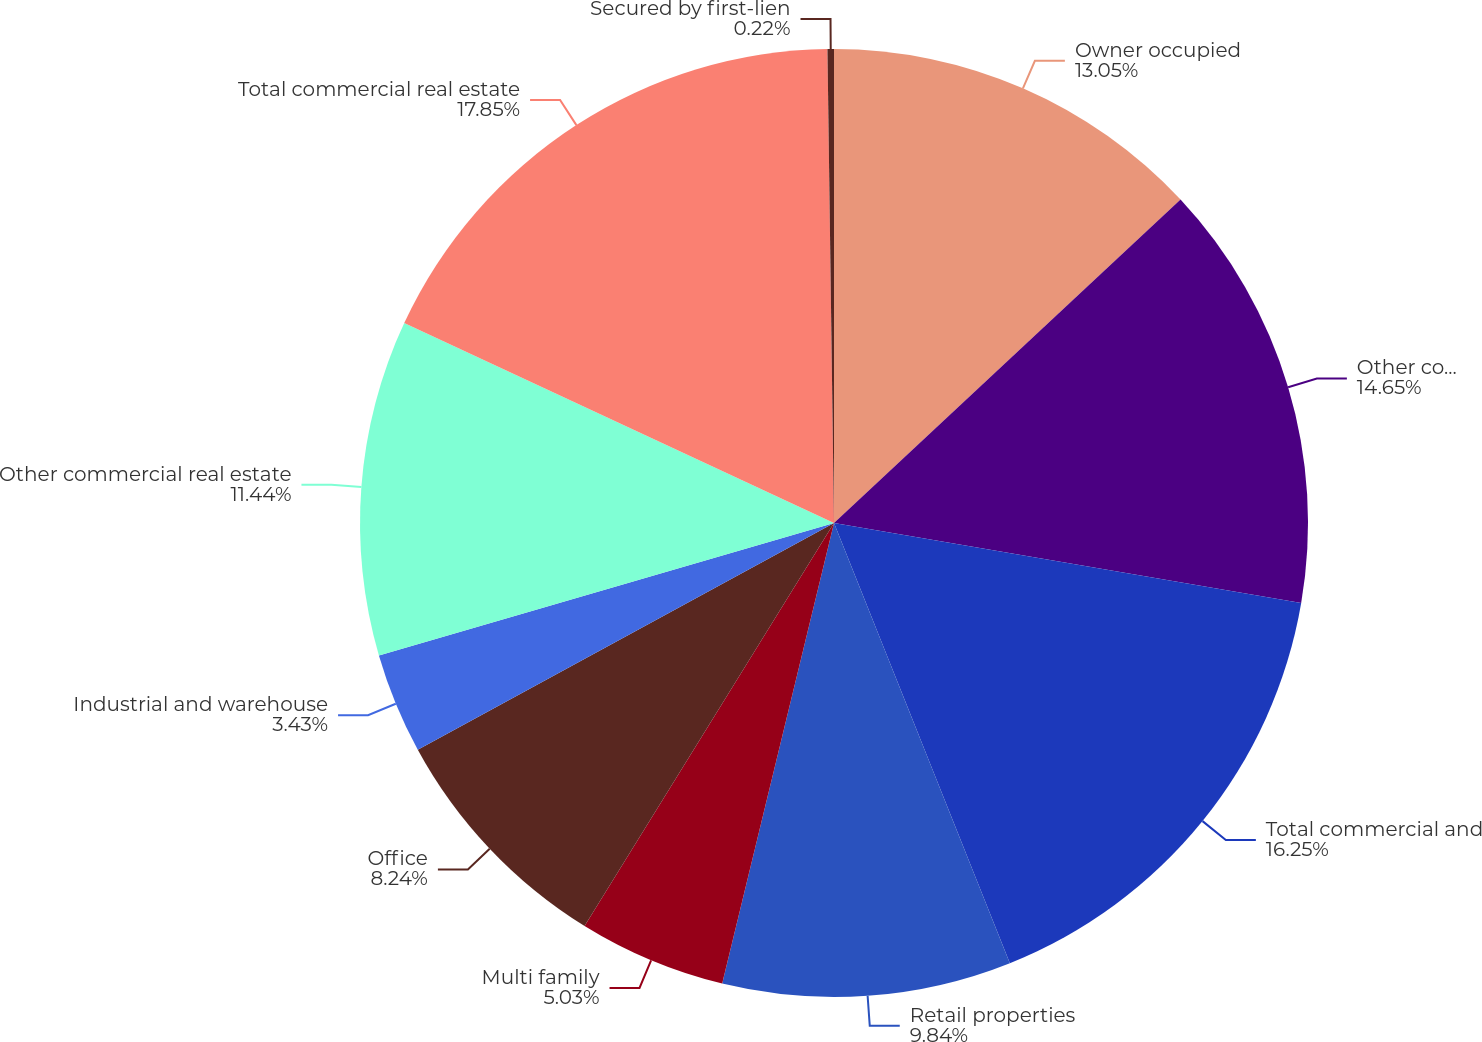Convert chart to OTSL. <chart><loc_0><loc_0><loc_500><loc_500><pie_chart><fcel>Owner occupied<fcel>Other commercial and<fcel>Total commercial and<fcel>Retail properties<fcel>Multi family<fcel>Office<fcel>Industrial and warehouse<fcel>Other commercial real estate<fcel>Total commercial real estate<fcel>Secured by first-lien<nl><fcel>13.05%<fcel>14.65%<fcel>16.25%<fcel>9.84%<fcel>5.03%<fcel>8.24%<fcel>3.43%<fcel>11.44%<fcel>17.85%<fcel>0.22%<nl></chart> 